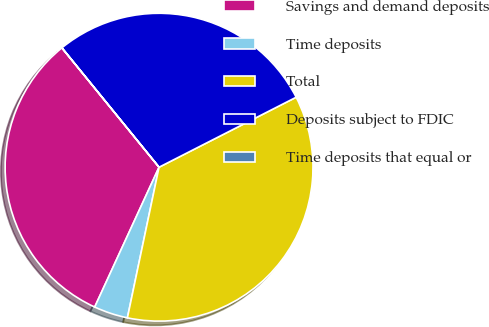Convert chart. <chart><loc_0><loc_0><loc_500><loc_500><pie_chart><fcel>Savings and demand deposits<fcel>Time deposits<fcel>Total<fcel>Deposits subject to FDIC<fcel>Time deposits that equal or<nl><fcel>32.26%<fcel>3.57%<fcel>35.81%<fcel>28.36%<fcel>0.01%<nl></chart> 